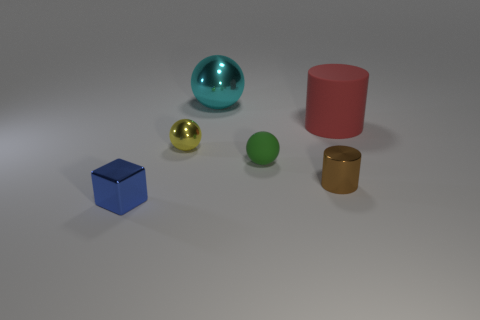Considering the lighting and shadows, where might the light source be in this scene? Based on the shadows cast by the objects, it seems that the primary light source is located above and to the left of the scene. The shadows are angled towards the bottom right, which indicates the direction of the light. 